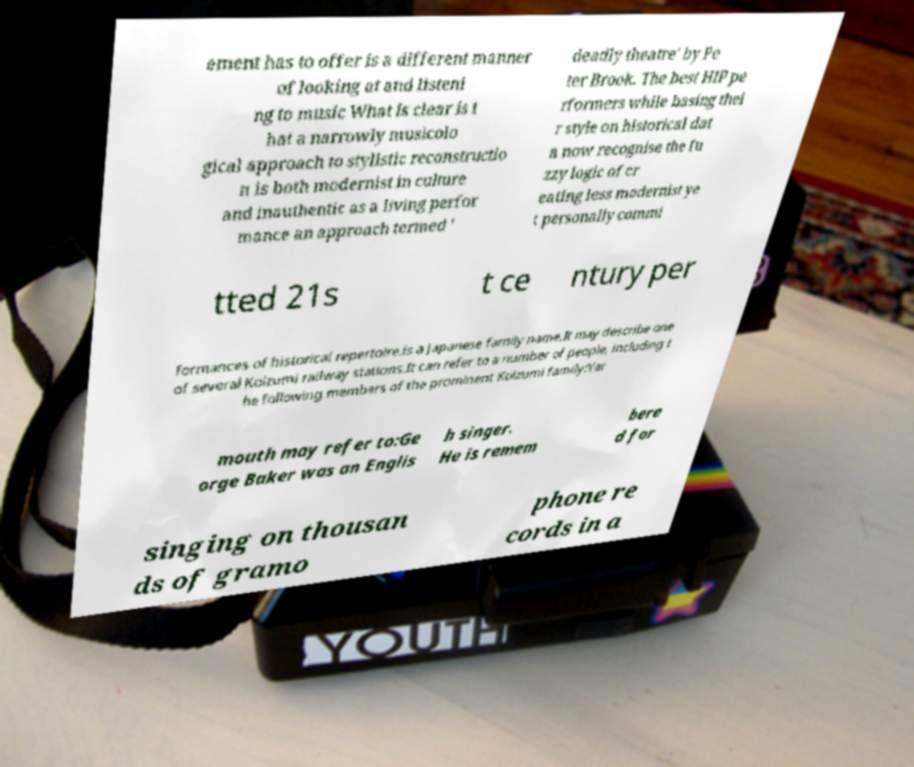I need the written content from this picture converted into text. Can you do that? ement has to offer is a different manner of looking at and listeni ng to music What is clear is t hat a narrowly musicolo gical approach to stylistic reconstructio n is both modernist in culture and inauthentic as a living perfor mance an approach termed ' deadly theatre' by Pe ter Brook. The best HIP pe rformers while basing thei r style on historical dat a now recognise the fu zzy logic of cr eating less modernist ye t personally commi tted 21s t ce ntury per formances of historical repertoire.is a Japanese family name.It may describe one of several Koizumi railway stations.It can refer to a number of people, including t he following members of the prominent Koizumi family:Yar mouth may refer to:Ge orge Baker was an Englis h singer. He is remem bere d for singing on thousan ds of gramo phone re cords in a 